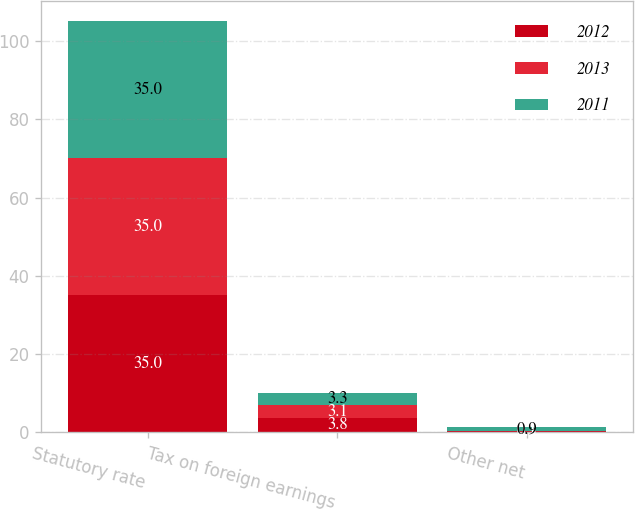<chart> <loc_0><loc_0><loc_500><loc_500><stacked_bar_chart><ecel><fcel>Statutory rate<fcel>Tax on foreign earnings<fcel>Other net<nl><fcel>2012<fcel>35<fcel>3.8<fcel>0.3<nl><fcel>2013<fcel>35<fcel>3.1<fcel>0.1<nl><fcel>2011<fcel>35<fcel>3.3<fcel>0.9<nl></chart> 